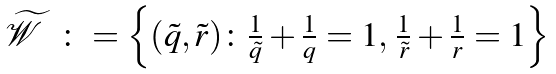Convert formula to latex. <formula><loc_0><loc_0><loc_500><loc_500>\begin{array} { l l } \widetilde { \mathcal { W } } & \colon = \left \{ ( \tilde { q } , \tilde { r } ) \colon \frac { 1 } { \tilde { q } } + \frac { 1 } { q } = 1 , \, \frac { 1 } { \tilde { r } } + \frac { 1 } { r } = 1 \right \} \end{array}</formula> 